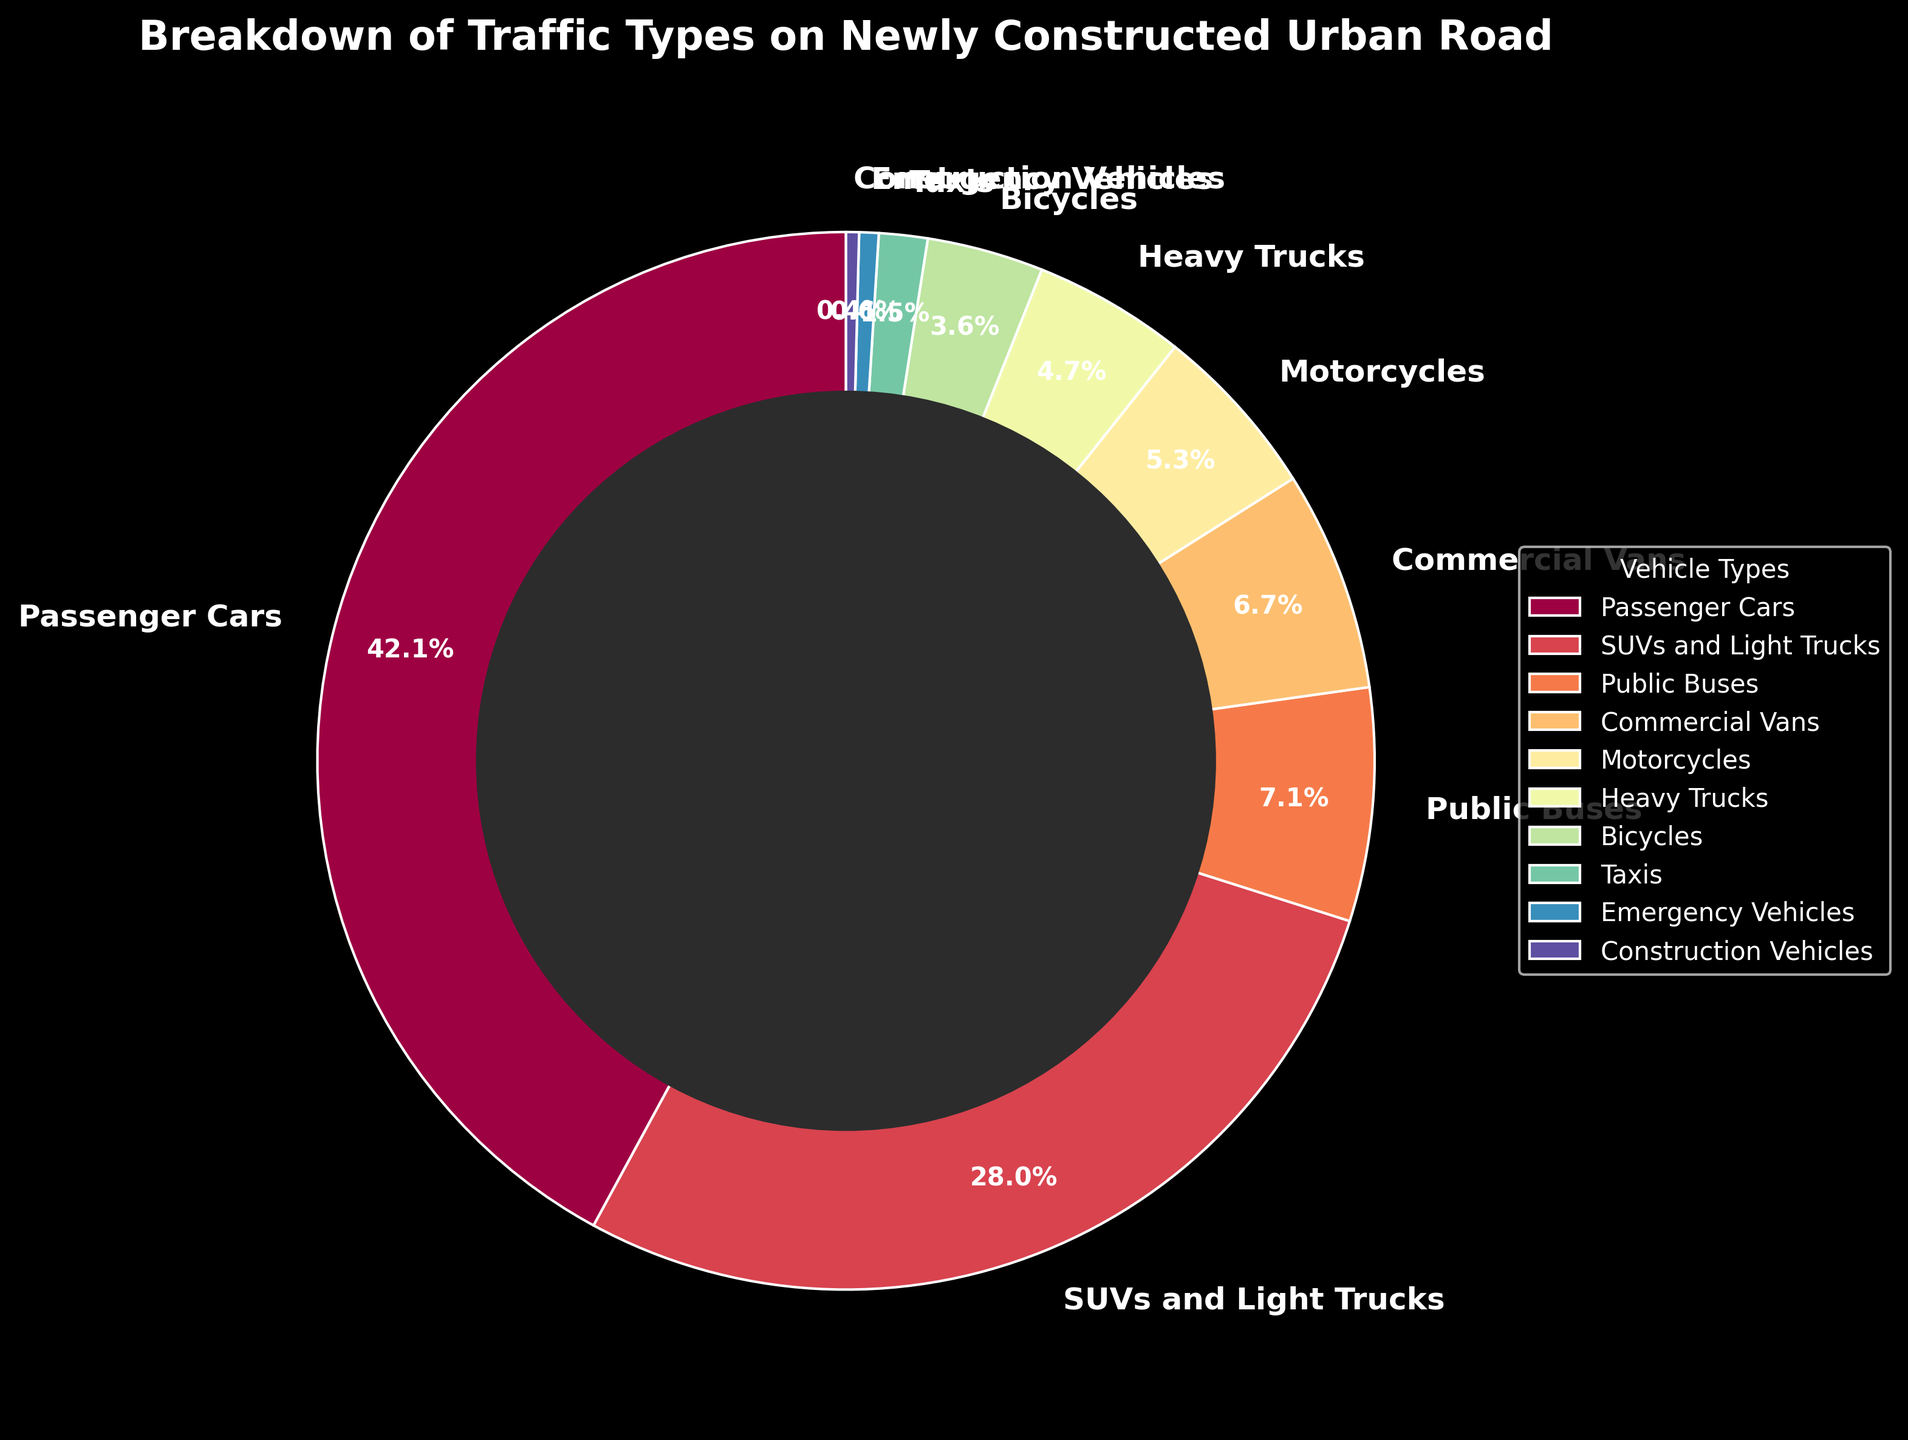What is the most common vehicle type on the urban road? The pie chart shows that passenger cars occupy the largest portion of the chart. By referring to the percentages, passenger cars have the highest percentage of 42.5%.
Answer: Passenger Cars Which vehicle type has the smallest representation on the urban road? By observing the smallest segment of the pie chart, you can see that construction vehicles have a percentage of 0.4%, which is the smallest compared to other vehicle types.
Answer: Construction Vehicles What is the combined percentage of passenger cars and SUVs/light trucks? According to the pie chart, passenger cars have a percentage of 42.5% and SUVs and light trucks have a percentage of 28.3%. Adding these two percentages together, we get 42.5% + 28.3% = 70.8%.
Answer: 70.8% How does the percentage of emergency vehicles compare to public buses? By looking at the pie chart, public buses have a percentage of 7.2% while emergency vehicles have a percentage of 0.6%. Public buses have a higher percentage compared to emergency vehicles.
Answer: Public buses have a higher percentage What is the percentage difference between motorcycles and commercial vans? Referring to the pie chart, motorcycles have a percentage of 5.4% and commercial vans have a percentage of 6.8%. Calculating the difference, we get 6.8% - 5.4% = 1.4%.
Answer: 1.4% Which vehicle types have a percentage higher than heavy trucks but less than passenger cars? Heavy trucks have a percentage of 4.7%, and passenger cars have a percentage of 42.5%. The vehicle types within this range are SUVs and light trucks (28.3%), public buses (7.2%), commercial vans (6.8%), and motorcycles (5.4%).
Answer: SUVs and light trucks, public buses, commercial vans, motorcycles What is the total percentage of vehicle types that individually constitute less than 5% of traffic? The vehicle types with less than 5% are motorcycles (5.4%), heavy trucks (4.7%), bicycles (3.6%), taxis (1.5%), emergency vehicles (0.6%), and construction vehicles (0.4%). Summing their percentages: 5.4% + 4.7% + 3.6% + 1.5% + 0.6% + 0.4% = 16.2%.
Answer: 16.2% Which vehicle type segment is colored in the first sequence of the Spectral colormap? The custom colors in the chart are based on the Spectral colormap sequence, which starts from light colors. From the pie chart, the first segment starts at zero degrees, representing passenger cars.
Answer: Passenger Cars 